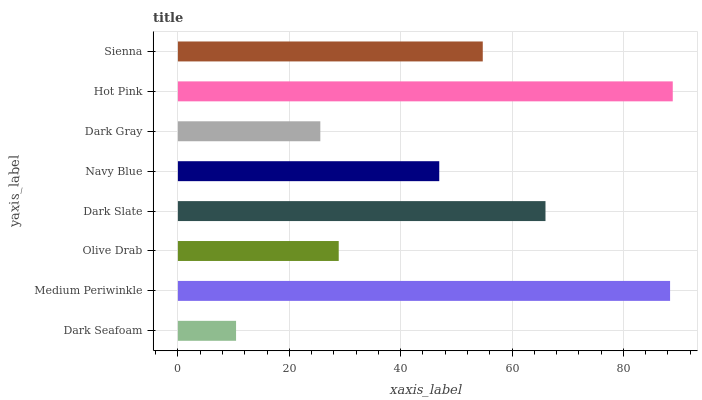Is Dark Seafoam the minimum?
Answer yes or no. Yes. Is Hot Pink the maximum?
Answer yes or no. Yes. Is Medium Periwinkle the minimum?
Answer yes or no. No. Is Medium Periwinkle the maximum?
Answer yes or no. No. Is Medium Periwinkle greater than Dark Seafoam?
Answer yes or no. Yes. Is Dark Seafoam less than Medium Periwinkle?
Answer yes or no. Yes. Is Dark Seafoam greater than Medium Periwinkle?
Answer yes or no. No. Is Medium Periwinkle less than Dark Seafoam?
Answer yes or no. No. Is Sienna the high median?
Answer yes or no. Yes. Is Navy Blue the low median?
Answer yes or no. Yes. Is Olive Drab the high median?
Answer yes or no. No. Is Sienna the low median?
Answer yes or no. No. 